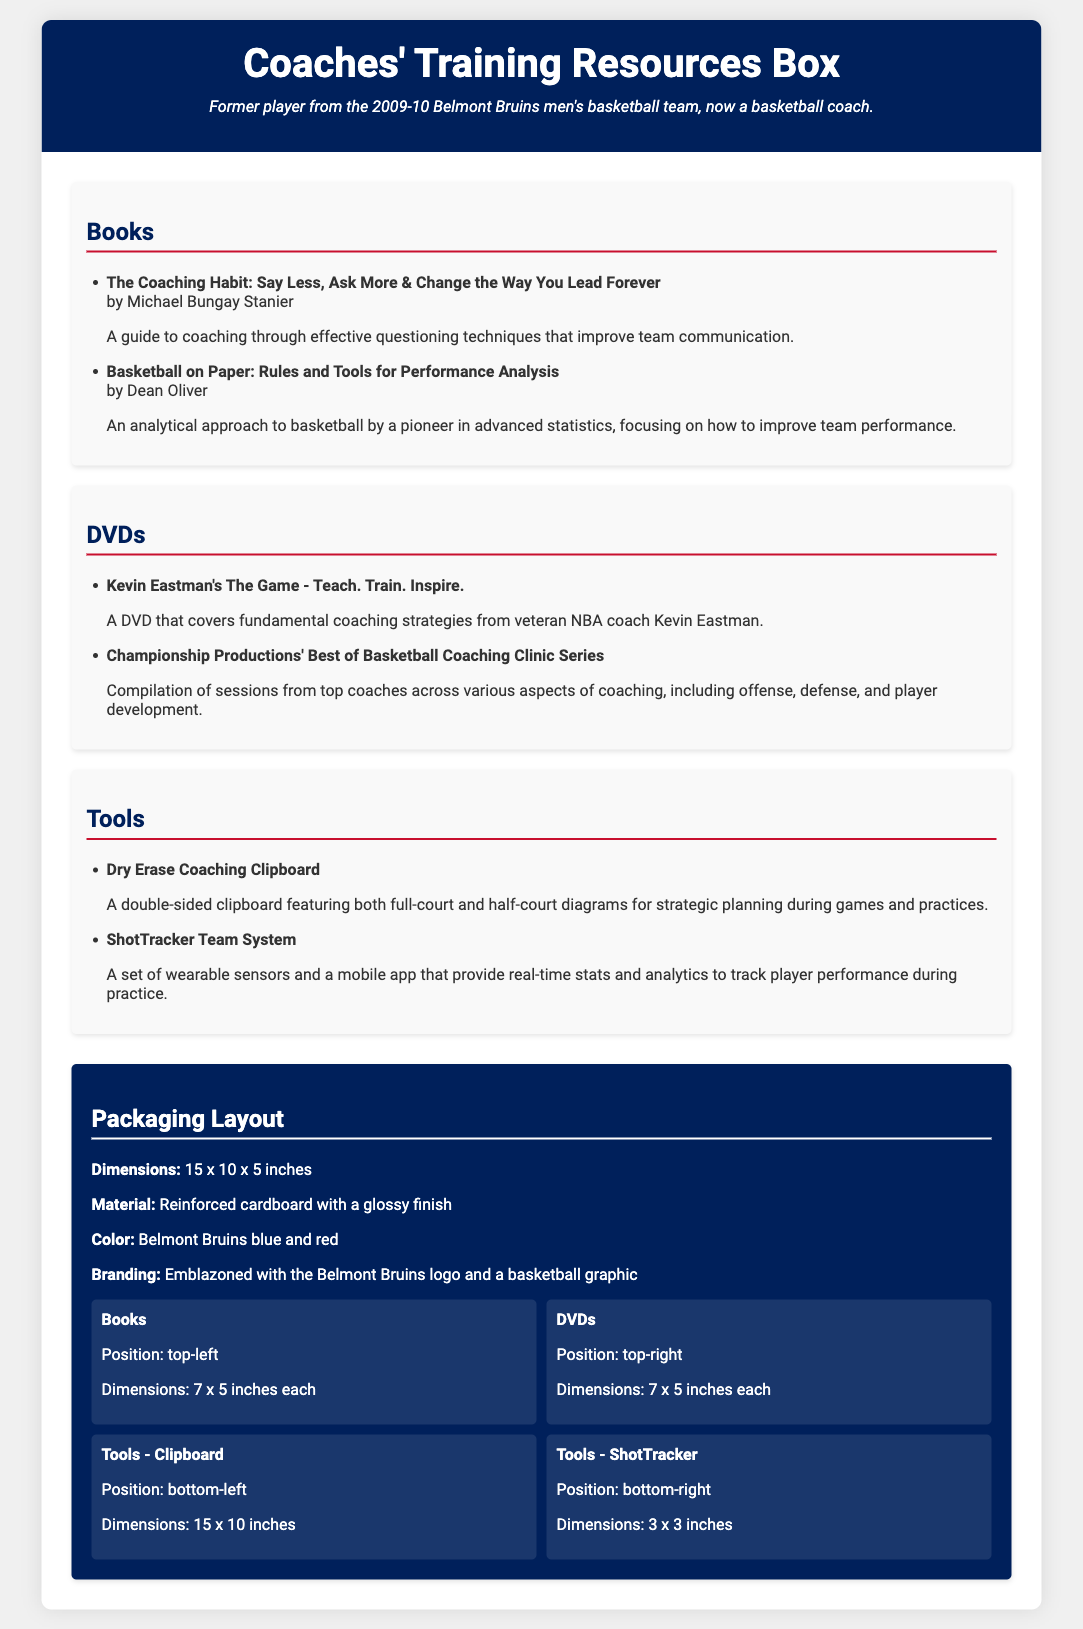What is the title of the first book listed? The first book listed is "The Coaching Habit: Say Less, Ask More & Change the Way You Lead Forever."
Answer: The Coaching Habit: Say Less, Ask More & Change the Way You Lead Forever How many DVDs are included in the resources box? Two DVDs are listed under the DVDs section of the document.
Answer: 2 What is the position of the Dry Erase Coaching Clipboard in the packaging layout? The Dry Erase Coaching Clipboard is positioned in the bottom-left section of the packaging layout.
Answer: bottom-left What are the dimensions of the packaging box? The document specifies the dimensions of the packaging box as 15 x 10 x 5 inches.
Answer: 15 x 10 x 5 inches Which color is featured in the packaging design? The packaging design features Belmont Bruins blue and red colors.
Answer: Belmont Bruins blue and red What is the main purpose of the ShotTracker Team System? The ShotTracker Team System provides real-time stats and analytics to track player performance during practice.
Answer: real-time stats and analytics to track player performance Who is the author of "Basketball on Paper"? The author of "Basketball on Paper" is Dean Oliver.
Answer: Dean Oliver How are the books organized in the packaging layout? The books are organized in the top-left position of the packaging layout.
Answer: top-left 